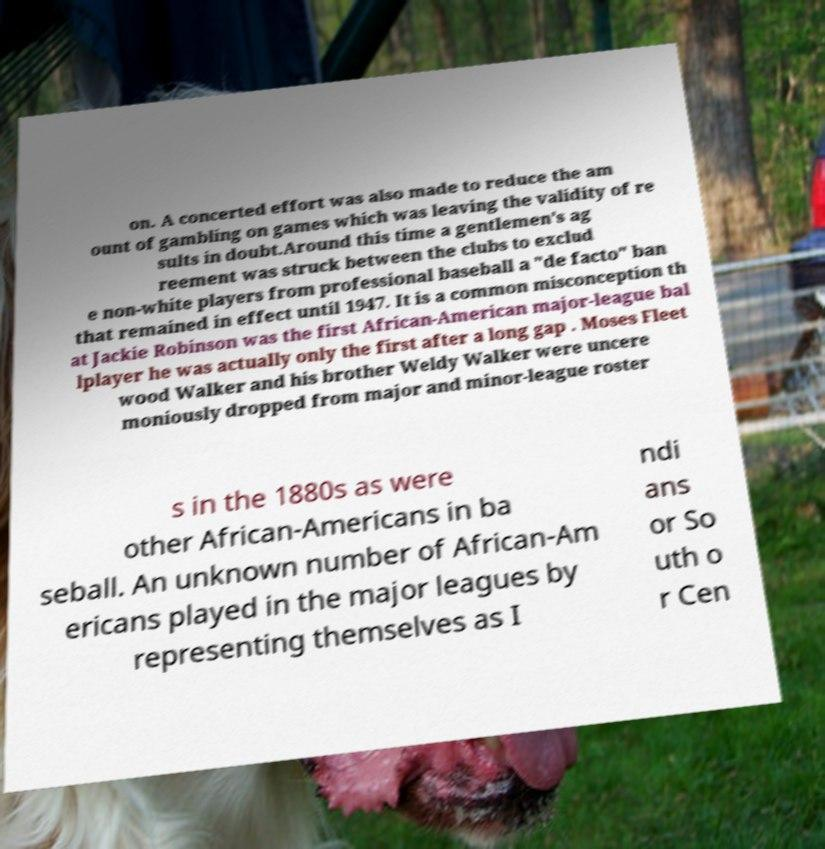Could you extract and type out the text from this image? on. A concerted effort was also made to reduce the am ount of gambling on games which was leaving the validity of re sults in doubt.Around this time a gentlemen's ag reement was struck between the clubs to exclud e non-white players from professional baseball a "de facto" ban that remained in effect until 1947. It is a common misconception th at Jackie Robinson was the first African-American major-league bal lplayer he was actually only the first after a long gap . Moses Fleet wood Walker and his brother Weldy Walker were uncere moniously dropped from major and minor-league roster s in the 1880s as were other African-Americans in ba seball. An unknown number of African-Am ericans played in the major leagues by representing themselves as I ndi ans or So uth o r Cen 